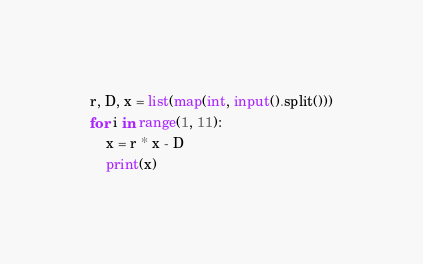Convert code to text. <code><loc_0><loc_0><loc_500><loc_500><_Python_>r, D, x = list(map(int, input().split()))
for i in range(1, 11):
	x = r * x - D
	print(x)
</code> 